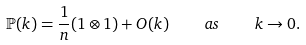<formula> <loc_0><loc_0><loc_500><loc_500>\mathbb { P } ( k ) = \frac { 1 } { n } ( 1 \otimes 1 ) + O ( k ) \quad a s \quad k \to 0 .</formula> 